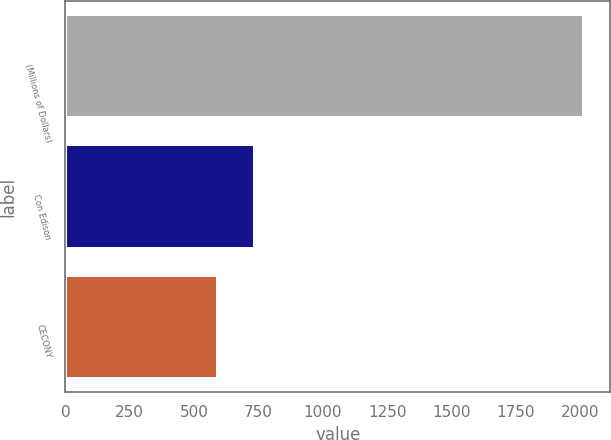Convert chart to OTSL. <chart><loc_0><loc_0><loc_500><loc_500><bar_chart><fcel>(Millions of Dollars)<fcel>Con Edison<fcel>CECONY<nl><fcel>2017<fcel>735.4<fcel>593<nl></chart> 